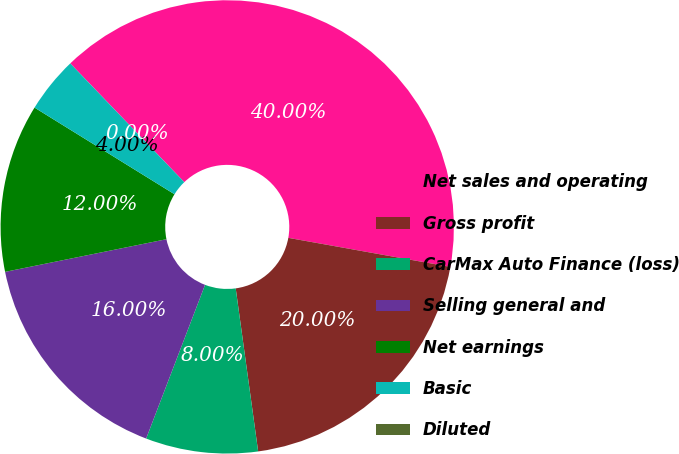<chart> <loc_0><loc_0><loc_500><loc_500><pie_chart><fcel>Net sales and operating<fcel>Gross profit<fcel>CarMax Auto Finance (loss)<fcel>Selling general and<fcel>Net earnings<fcel>Basic<fcel>Diluted<nl><fcel>40.0%<fcel>20.0%<fcel>8.0%<fcel>16.0%<fcel>12.0%<fcel>4.0%<fcel>0.0%<nl></chart> 